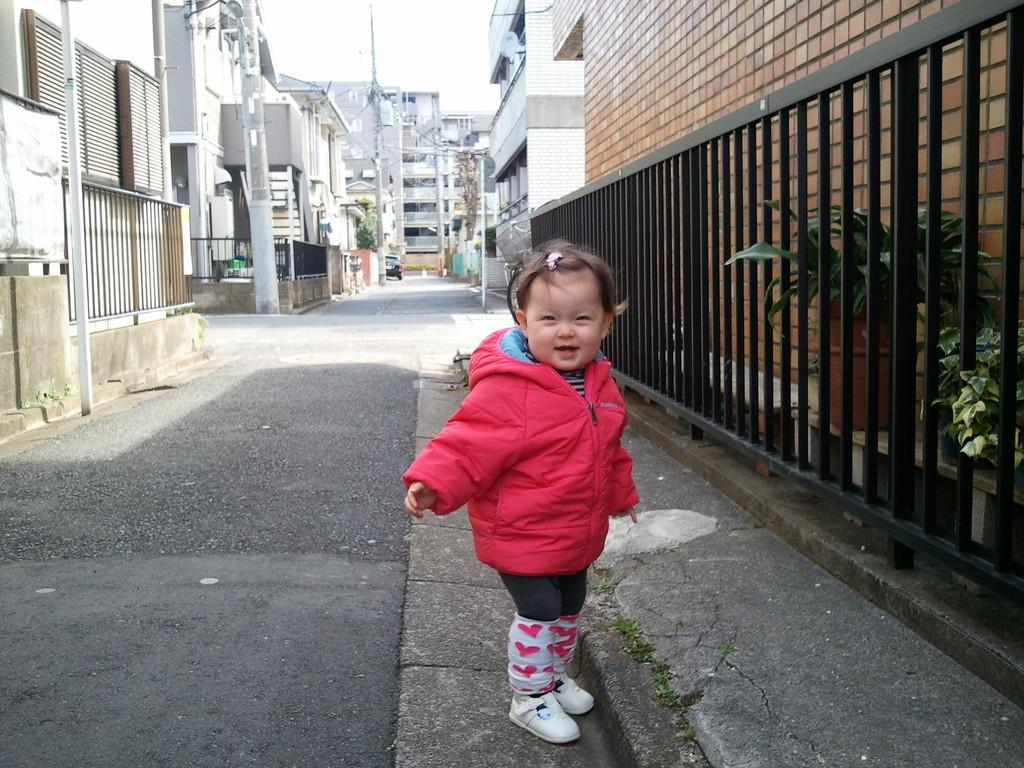What is the main subject of the image? There is a girl standing in the image. What is located near the girl in the image? There is a fence in the image. What can be seen behind the fence? House plants are visible behind the fence. What is behind the house plants? There is a wall behind the fence. What is visible in the background of the image? Buildings, poles, and the sky are visible in the background of the image. What verse is being recited by the girl in the image? There is no indication in the image that the girl is reciting a verse, so it cannot be determined from the picture. 